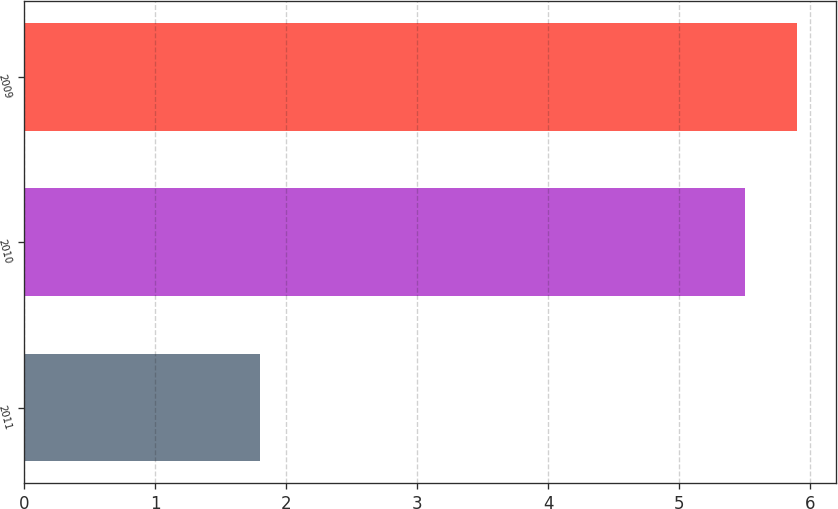Convert chart to OTSL. <chart><loc_0><loc_0><loc_500><loc_500><bar_chart><fcel>2011<fcel>2010<fcel>2009<nl><fcel>1.8<fcel>5.5<fcel>5.9<nl></chart> 